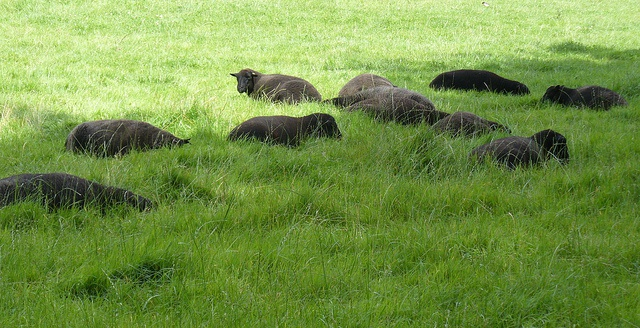Describe the objects in this image and their specific colors. I can see sheep in khaki, black, gray, and darkgreen tones, sheep in khaki, black, gray, and darkgreen tones, sheep in khaki, gray, black, and darkgreen tones, sheep in khaki, black, gray, and darkgreen tones, and sheep in khaki, black, gray, and darkgreen tones in this image. 